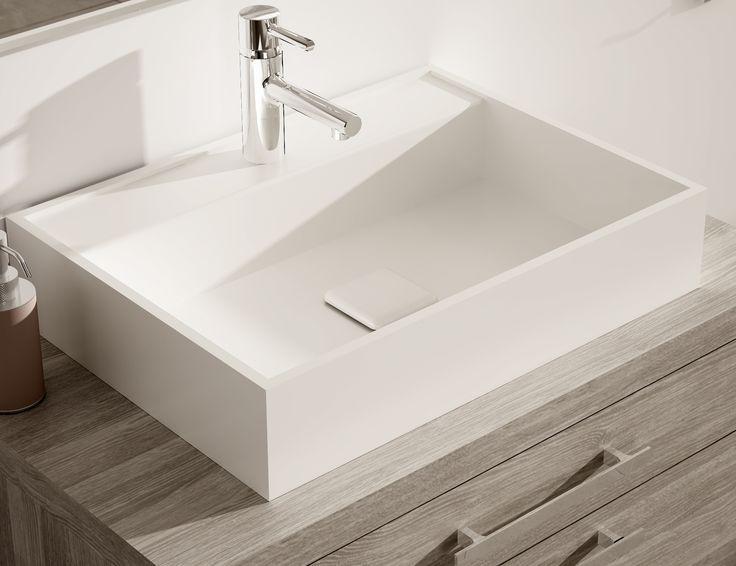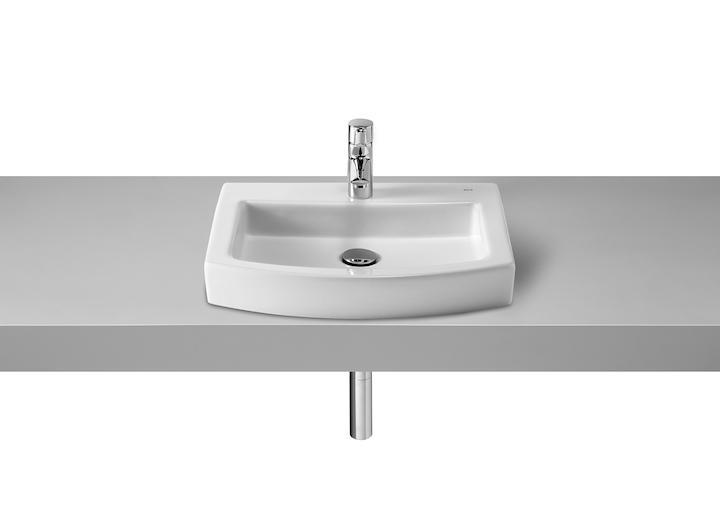The first image is the image on the left, the second image is the image on the right. Given the left and right images, does the statement "A vanity includes one rectangular white sink and a brown cabinet with multiple drawers." hold true? Answer yes or no. Yes. 